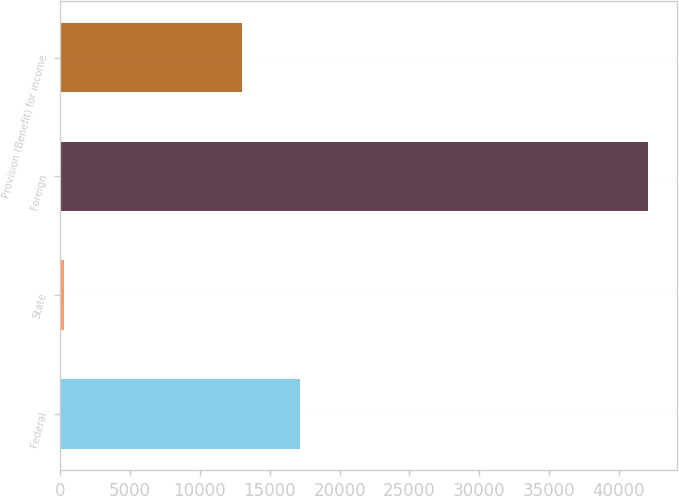<chart> <loc_0><loc_0><loc_500><loc_500><bar_chart><fcel>Federal<fcel>State<fcel>Foreign<fcel>Provision (Benefit) for income<nl><fcel>17198.6<fcel>279<fcel>42085<fcel>13018<nl></chart> 